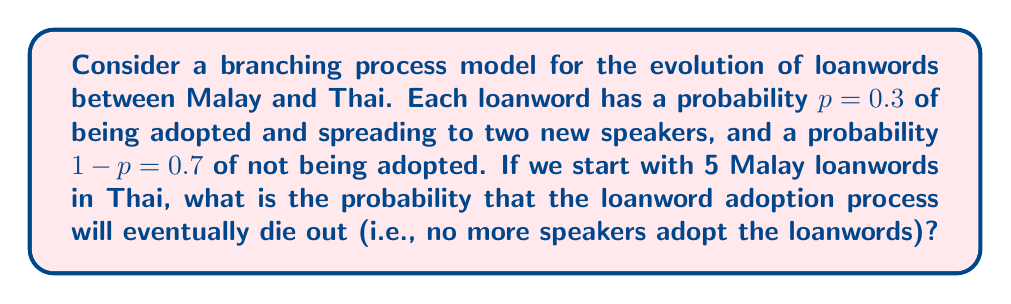Can you answer this question? To solve this problem, we'll use the theory of branching processes:

1) In a branching process, the probability of extinction, $q$, satisfies the equation:
   $q = f(q)$, where $f(s)$ is the probability generating function.

2) For our case, $f(s) = 0.7 + 0.3s^2$, because:
   - With probability 0.7, the loanword dies out (generating 0 offspring)
   - With probability 0.3, the loanword spreads to 2 new speakers

3) So, we need to solve: $q = 0.7 + 0.3q^2$

4) This is a quadratic equation. Rearranging:
   $0.3q^2 - q + 0.7 = 0$

5) Using the quadratic formula, $q = \frac{1 \pm \sqrt{1 - 4(0.3)(0.7)}}{2(0.3)}$

6) Simplifying: $q = \frac{1 \pm \sqrt{0.16}}{0.6} = \frac{1 \pm 0.4}{0.6}$

7) This gives us two solutions: $q = \frac{1.4}{0.6} \approx 2.33$ or $q = \frac{0.6}{0.6} = 1$

8) Since $q$ is a probability, it must be between 0 and 1, so $q = 1$ is the valid solution.

9) This $q$ represents the probability of extinction for a single loanword.

10) For 5 independent loanwords, the probability that they all die out is $q^5 = 1^5 = 1$

Therefore, the probability that the loanword adoption process will eventually die out, starting with 5 Malay loanwords, is 1.
Answer: 1 